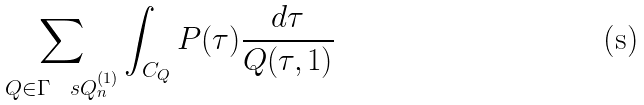Convert formula to latex. <formula><loc_0><loc_0><loc_500><loc_500>\sum _ { Q \in \Gamma \ \ s Q _ { n } ^ { ( 1 ) } } \int _ { C _ { Q } } P ( \tau ) \frac { d \tau } { Q ( \tau , 1 ) }</formula> 